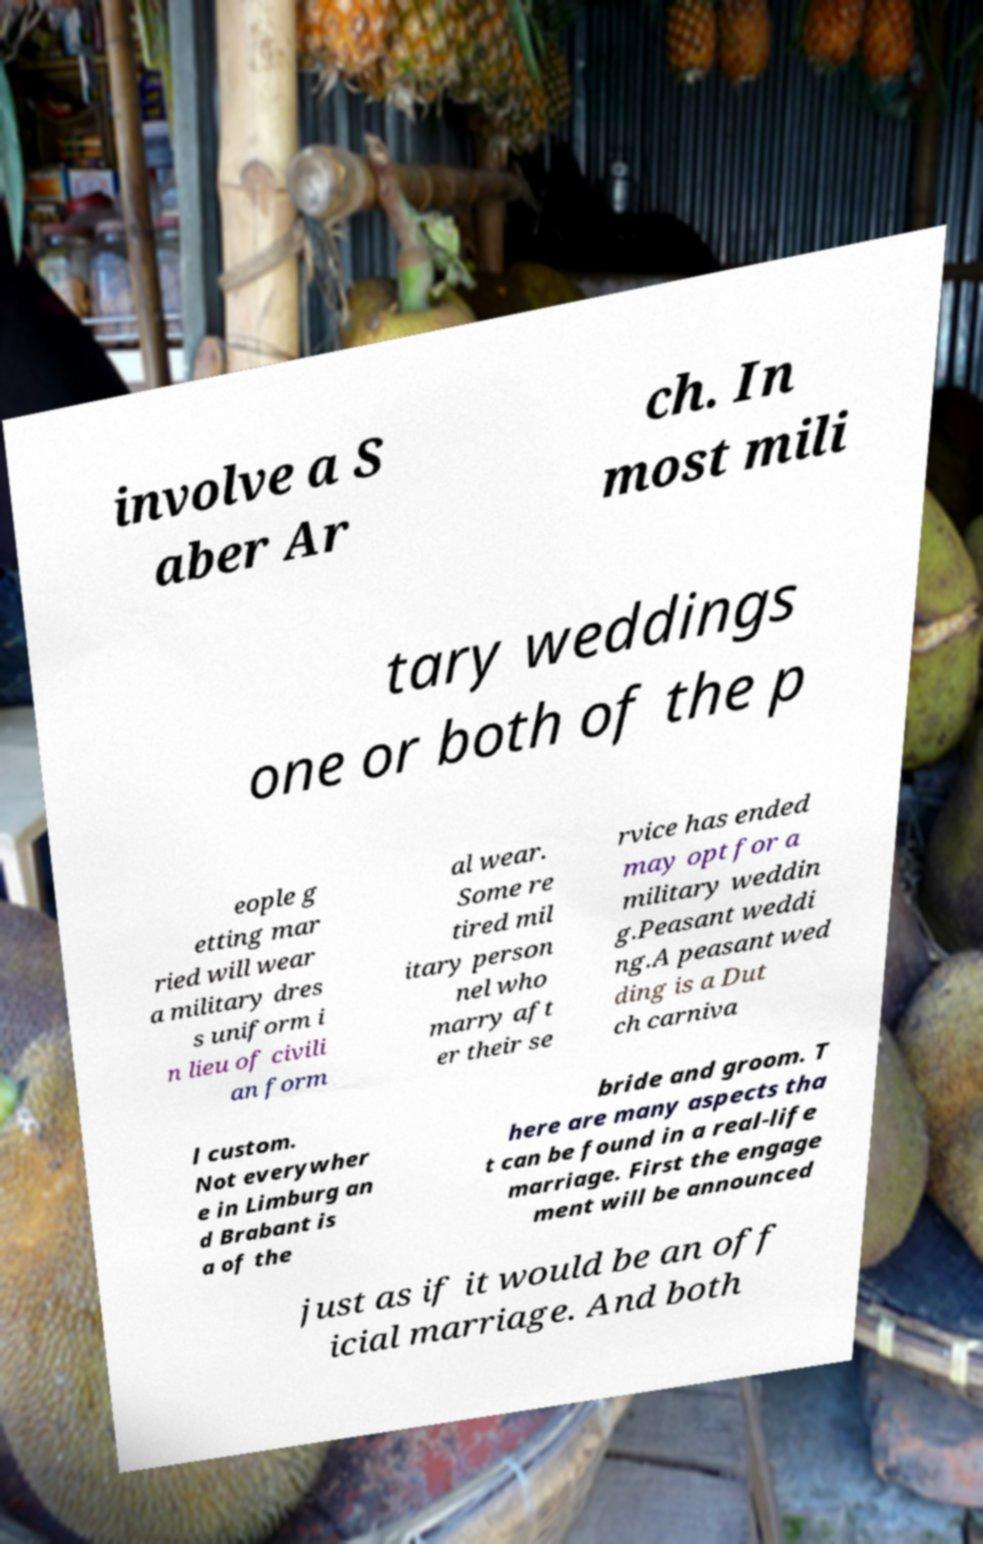Please read and relay the text visible in this image. What does it say? involve a S aber Ar ch. In most mili tary weddings one or both of the p eople g etting mar ried will wear a military dres s uniform i n lieu of civili an form al wear. Some re tired mil itary person nel who marry aft er their se rvice has ended may opt for a military weddin g.Peasant weddi ng.A peasant wed ding is a Dut ch carniva l custom. Not everywher e in Limburg an d Brabant is a of the bride and groom. T here are many aspects tha t can be found in a real-life marriage. First the engage ment will be announced just as if it would be an off icial marriage. And both 